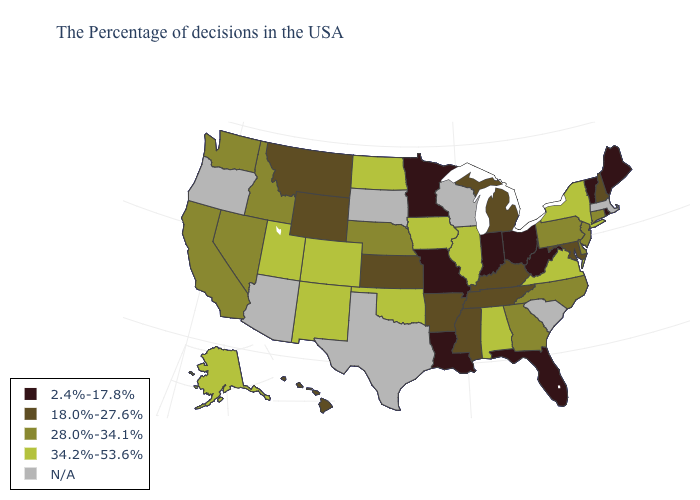Among the states that border North Dakota , which have the highest value?
Quick response, please. Montana. What is the lowest value in the USA?
Concise answer only. 2.4%-17.8%. Is the legend a continuous bar?
Be succinct. No. What is the highest value in states that border New Jersey?
Give a very brief answer. 34.2%-53.6%. Does Montana have the highest value in the USA?
Short answer required. No. What is the highest value in the Northeast ?
Give a very brief answer. 34.2%-53.6%. Name the states that have a value in the range 18.0%-27.6%?
Write a very short answer. New Hampshire, Maryland, Michigan, Kentucky, Tennessee, Mississippi, Arkansas, Kansas, Wyoming, Montana, Hawaii. Name the states that have a value in the range 34.2%-53.6%?
Write a very short answer. New York, Virginia, Alabama, Illinois, Iowa, Oklahoma, North Dakota, Colorado, New Mexico, Utah, Alaska. Name the states that have a value in the range 2.4%-17.8%?
Write a very short answer. Maine, Rhode Island, Vermont, West Virginia, Ohio, Florida, Indiana, Louisiana, Missouri, Minnesota. Does the first symbol in the legend represent the smallest category?
Be succinct. Yes. Which states hav the highest value in the South?
Write a very short answer. Virginia, Alabama, Oklahoma. How many symbols are there in the legend?
Answer briefly. 5. Name the states that have a value in the range 28.0%-34.1%?
Keep it brief. Connecticut, New Jersey, Delaware, Pennsylvania, North Carolina, Georgia, Nebraska, Idaho, Nevada, California, Washington. Which states have the lowest value in the USA?
Keep it brief. Maine, Rhode Island, Vermont, West Virginia, Ohio, Florida, Indiana, Louisiana, Missouri, Minnesota. 